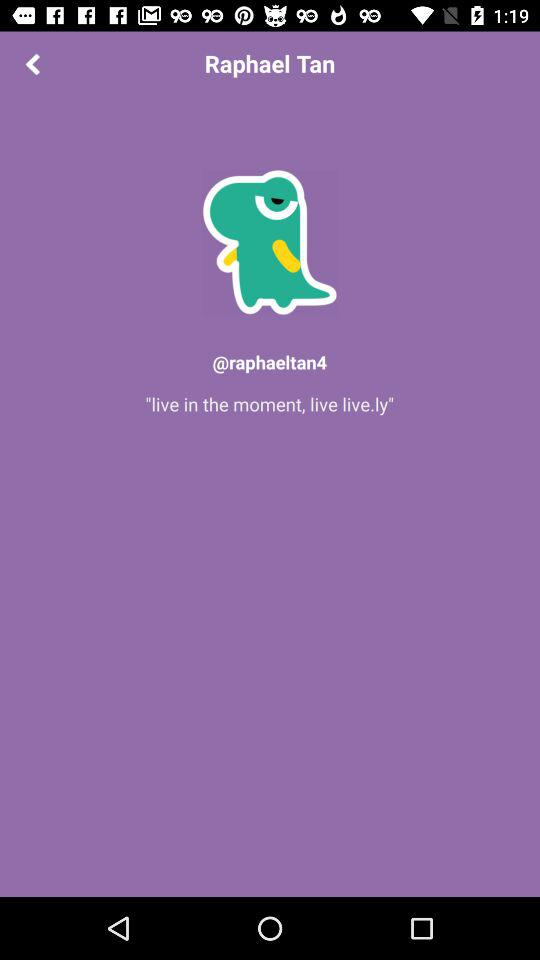What is the user name? The user name is Raphael Tan. 